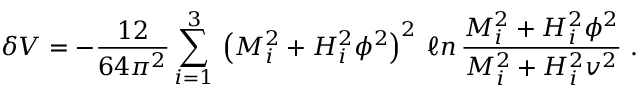<formula> <loc_0><loc_0><loc_500><loc_500>\delta V = - \frac { 1 2 } { 6 4 \pi ^ { 2 } } \sum _ { i = 1 } ^ { 3 } \, \left ( M _ { i } ^ { 2 } + H _ { i } ^ { 2 } \phi ^ { 2 } \right ) ^ { 2 } \, \ell n \, \frac { M _ { i } ^ { 2 } + H _ { i } ^ { 2 } \phi ^ { 2 } } { M _ { i } ^ { 2 } + H _ { i } ^ { 2 } v ^ { 2 } } \ .</formula> 